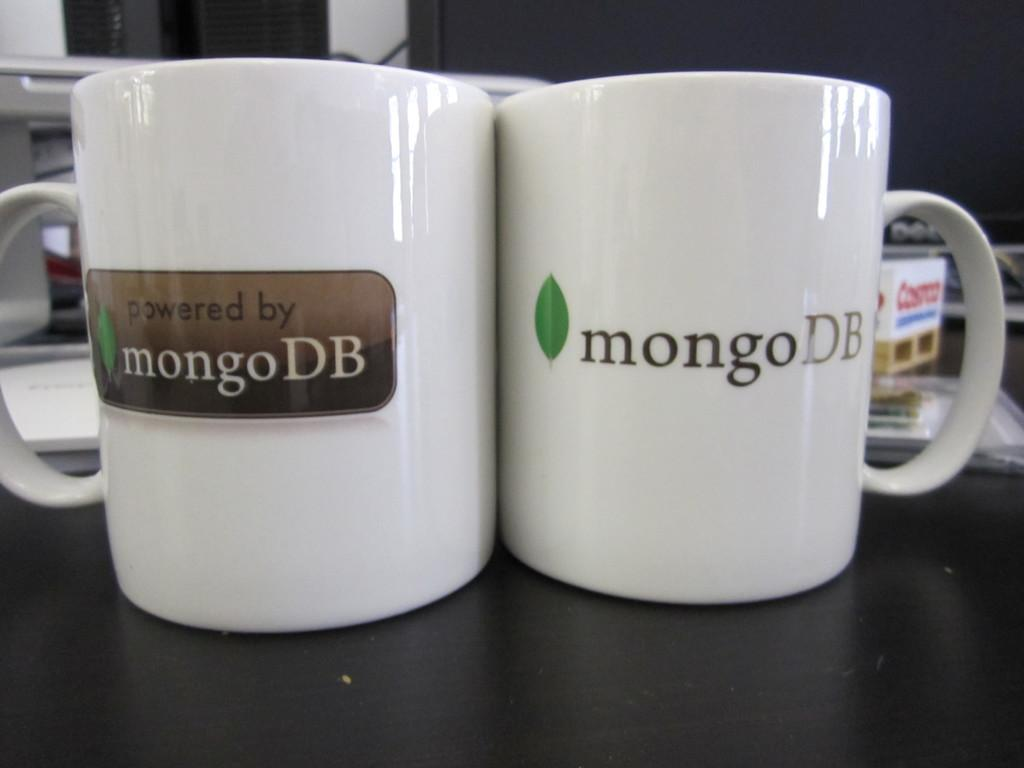<image>
Relay a brief, clear account of the picture shown. Two white coffee cups emblazoned with the logo for mongoDB. 